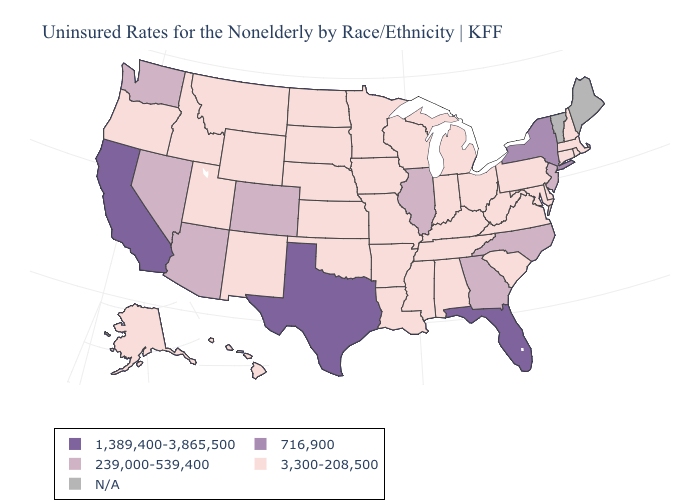Does Texas have the highest value in the USA?
Keep it brief. Yes. What is the value of Illinois?
Concise answer only. 239,000-539,400. What is the lowest value in states that border Tennessee?
Short answer required. 3,300-208,500. Which states have the highest value in the USA?
Quick response, please. California, Florida, Texas. Does Georgia have the highest value in the USA?
Be succinct. No. Does Illinois have the lowest value in the MidWest?
Answer briefly. No. Name the states that have a value in the range 3,300-208,500?
Answer briefly. Alabama, Alaska, Arkansas, Connecticut, Delaware, Hawaii, Idaho, Indiana, Iowa, Kansas, Kentucky, Louisiana, Maryland, Massachusetts, Michigan, Minnesota, Mississippi, Missouri, Montana, Nebraska, New Hampshire, New Mexico, North Dakota, Ohio, Oklahoma, Oregon, Pennsylvania, Rhode Island, South Carolina, South Dakota, Tennessee, Utah, Virginia, West Virginia, Wisconsin, Wyoming. Does Wisconsin have the highest value in the USA?
Concise answer only. No. Does Kentucky have the lowest value in the USA?
Keep it brief. Yes. What is the value of Idaho?
Answer briefly. 3,300-208,500. Is the legend a continuous bar?
Short answer required. No. Which states have the lowest value in the USA?
Give a very brief answer. Alabama, Alaska, Arkansas, Connecticut, Delaware, Hawaii, Idaho, Indiana, Iowa, Kansas, Kentucky, Louisiana, Maryland, Massachusetts, Michigan, Minnesota, Mississippi, Missouri, Montana, Nebraska, New Hampshire, New Mexico, North Dakota, Ohio, Oklahoma, Oregon, Pennsylvania, Rhode Island, South Carolina, South Dakota, Tennessee, Utah, Virginia, West Virginia, Wisconsin, Wyoming. What is the value of Georgia?
Write a very short answer. 239,000-539,400. Which states hav the highest value in the West?
Answer briefly. California. Name the states that have a value in the range 1,389,400-3,865,500?
Short answer required. California, Florida, Texas. 